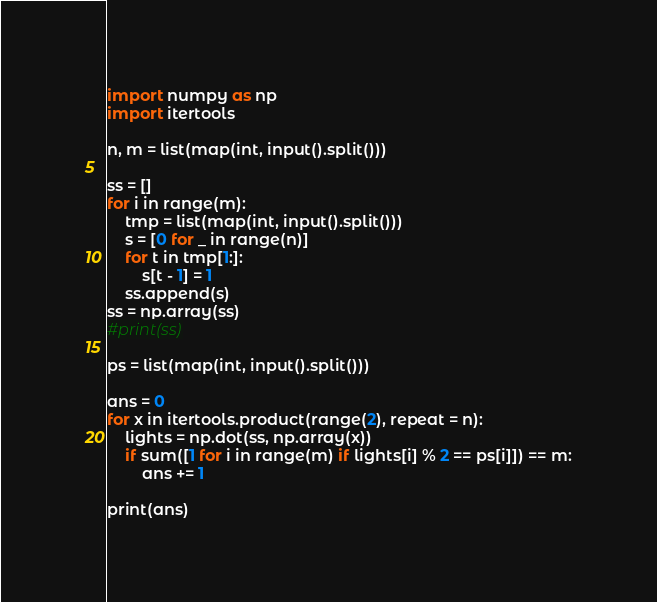<code> <loc_0><loc_0><loc_500><loc_500><_Python_>import numpy as np
import itertools

n, m = list(map(int, input().split()))

ss = []
for i in range(m):
	tmp = list(map(int, input().split()))
	s = [0 for _ in range(n)]
	for t in tmp[1:]:
		s[t - 1] = 1
	ss.append(s)
ss = np.array(ss)
#print(ss)

ps = list(map(int, input().split()))

ans = 0
for x in itertools.product(range(2), repeat = n):
	lights = np.dot(ss, np.array(x))
	if sum([1 for i in range(m) if lights[i] % 2 == ps[i]]) == m:
		ans += 1

print(ans)</code> 